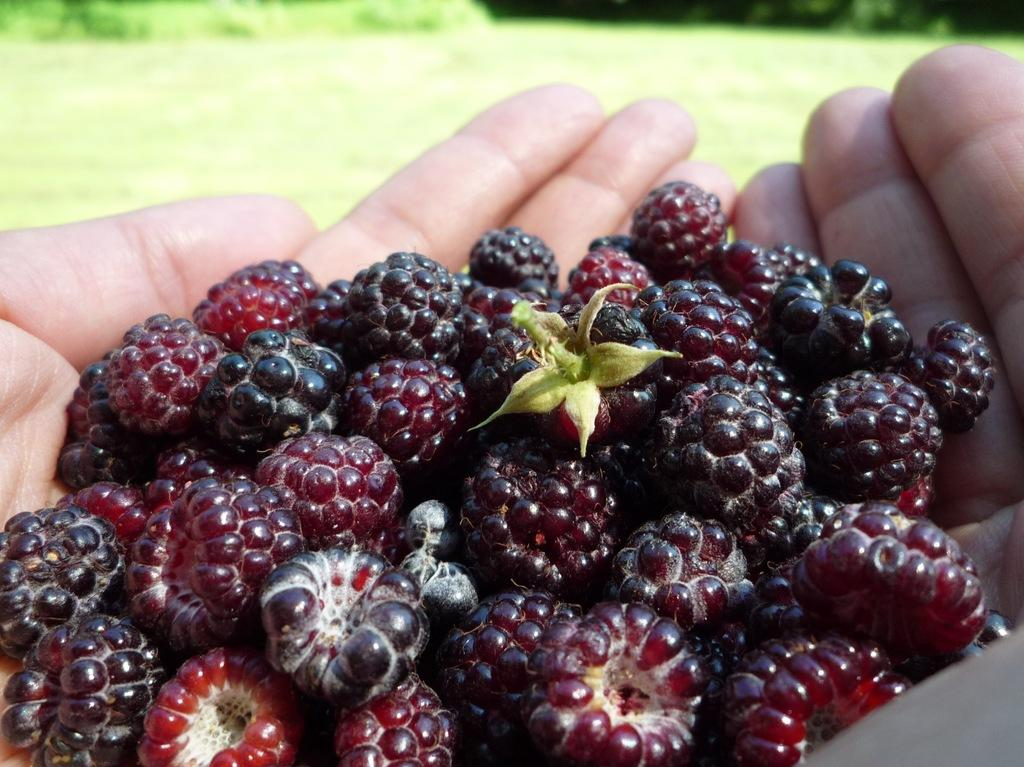Who or what is in the front of the image? There is a person in the front of the image. What is the person holding in their hand? The person is holding a fruit in their hand. What can be seen in the background of the image? There is grass in the background of the image. What grade does the faucet receive in the image? There is no faucet present in the image, so it cannot receive a grade. 